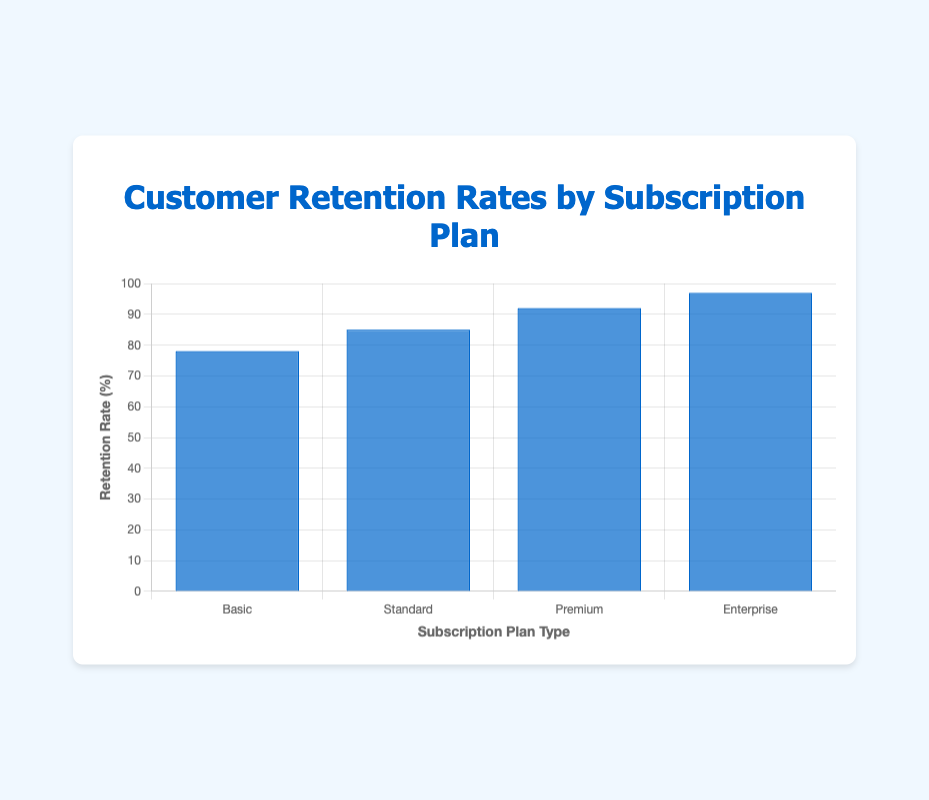What is the retention rate of the Enterprise subscription plan? The Enterprise subscription plan shows an individual bar reaching 97% on the y-axis, indicating the retention rate for that plan.
Answer: 97% Which subscription plan type has the lowest retention rate? By comparing the heights of the bars, the Basic plan has the shortest bar, indicating it has the lowest retention rate of 78%.
Answer: Basic How much higher is the retention rate for the Premium plan compared to the Basic plan? The retention rate for the Premium plan is 92%, while it's 78% for the Basic plan. The difference is 92% - 78% = 14%.
Answer: 14% What is the average retention rate across all subscription plans? Sum the retention rates: 78 + 85 + 92 + 97 = 352. There are 4 plans, so the average rate is 352 / 4 = 88%.
Answer: 88% If the Standard plan's retention rate increased by 5%, how would its rate compare to the Premium plan's rate? The current retention rate for the Standard plan is 85%. An increase of 5% would make it 85% + 5% = 90%, which is still 2% lower than the Premium plan's rate of 92%.
Answer: 2% lower Which subscription plan shows an increase of more than 8% when compared to the plan with the next lower retention rate? The Premium plan has a retention rate of 92%, which is 7% higher than the Standard plan’s 85%. The Enterprise plan’s 97% is 5% higher than the Premium plan's rate. The comparison that meets the condition is from the Basic plan’s 78% to the Standard plan’s 85%, an increase of 7%. None meet the 8% or more increase.
Answer: None Rank the subscription plans by retention rate from highest to lowest. By comparing the heights of the bars from left to right, Enterprise (97%), Premium (92%), Standard (85%), and Basic (78%).
Answer: Enterprise, Premium, Standard, Basic What is the combined retention rate of the Standard and Enterprise plans? The retention rates are 85% for the Standard plan and 97% for the Enterprise plan. The combined retention rate is 85% + 97% = 182%.
Answer: 182% How much higher is the retention rate of the Enterprise plan compared to the average retention rate across all plans? The average retention rate calculated earlier is 88%. The difference is 97% (Enterprise) - 88% (average) = 9%.
Answer: 9% 